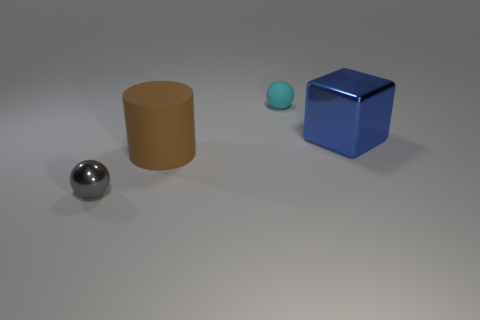Are there any other things that have the same shape as the big shiny object?
Provide a short and direct response. No. There is a metallic object in front of the metal block; is its size the same as the sphere behind the gray object?
Make the answer very short. Yes. There is a small thing that is behind the large object that is on the left side of the tiny sphere behind the tiny gray sphere; what is its shape?
Offer a very short reply. Sphere. There is another thing that is the same shape as the small cyan object; what size is it?
Provide a succinct answer. Small. There is a thing that is both right of the gray object and left of the tiny cyan sphere; what is its color?
Your answer should be very brief. Brown. Is the blue thing made of the same material as the big thing that is on the left side of the matte sphere?
Offer a very short reply. No. Are there fewer big things on the left side of the cyan rubber ball than tiny spheres?
Ensure brevity in your answer.  Yes. How many other things are the same shape as the cyan thing?
Keep it short and to the point. 1. Are there any other things of the same color as the large rubber object?
Ensure brevity in your answer.  No. What number of other things are the same size as the gray shiny thing?
Your answer should be very brief. 1. 